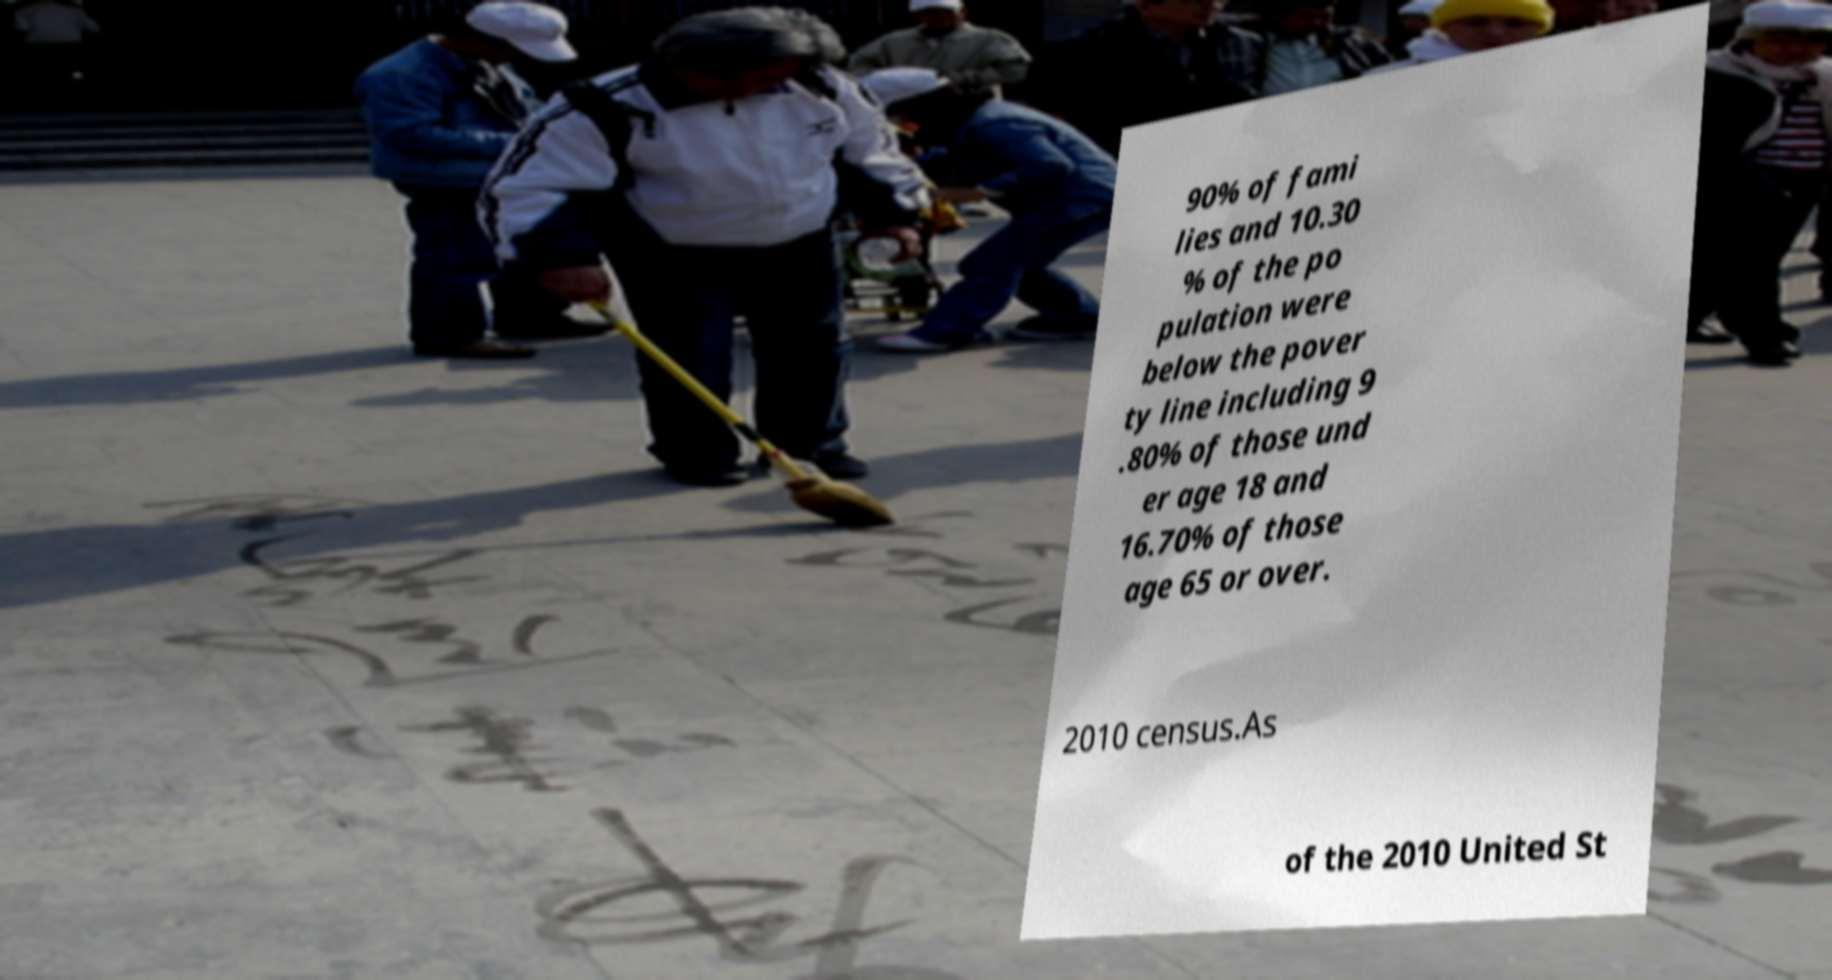There's text embedded in this image that I need extracted. Can you transcribe it verbatim? 90% of fami lies and 10.30 % of the po pulation were below the pover ty line including 9 .80% of those und er age 18 and 16.70% of those age 65 or over. 2010 census.As of the 2010 United St 